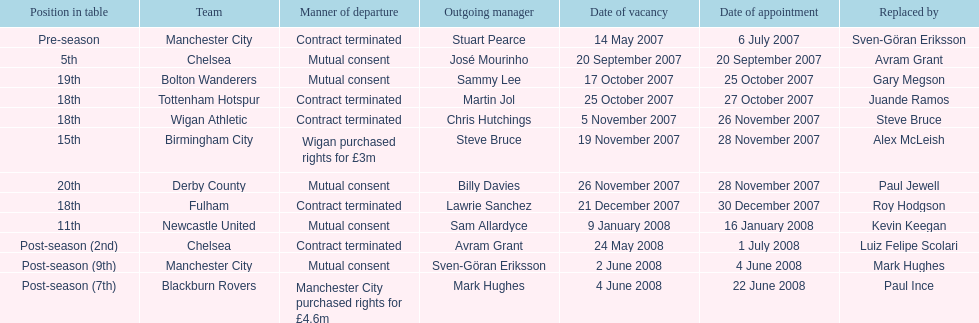Could you parse the entire table? {'header': ['Position in table', 'Team', 'Manner of departure', 'Outgoing manager', 'Date of vacancy', 'Date of appointment', 'Replaced by'], 'rows': [['Pre-season', 'Manchester City', 'Contract terminated', 'Stuart Pearce', '14 May 2007', '6 July 2007', 'Sven-Göran Eriksson'], ['5th', 'Chelsea', 'Mutual consent', 'José Mourinho', '20 September 2007', '20 September 2007', 'Avram Grant'], ['19th', 'Bolton Wanderers', 'Mutual consent', 'Sammy Lee', '17 October 2007', '25 October 2007', 'Gary Megson'], ['18th', 'Tottenham Hotspur', 'Contract terminated', 'Martin Jol', '25 October 2007', '27 October 2007', 'Juande Ramos'], ['18th', 'Wigan Athletic', 'Contract terminated', 'Chris Hutchings', '5 November 2007', '26 November 2007', 'Steve Bruce'], ['15th', 'Birmingham City', 'Wigan purchased rights for £3m', 'Steve Bruce', '19 November 2007', '28 November 2007', 'Alex McLeish'], ['20th', 'Derby County', 'Mutual consent', 'Billy Davies', '26 November 2007', '28 November 2007', 'Paul Jewell'], ['18th', 'Fulham', 'Contract terminated', 'Lawrie Sanchez', '21 December 2007', '30 December 2007', 'Roy Hodgson'], ['11th', 'Newcastle United', 'Mutual consent', 'Sam Allardyce', '9 January 2008', '16 January 2008', 'Kevin Keegan'], ['Post-season (2nd)', 'Chelsea', 'Contract terminated', 'Avram Grant', '24 May 2008', '1 July 2008', 'Luiz Felipe Scolari'], ['Post-season (9th)', 'Manchester City', 'Mutual consent', 'Sven-Göran Eriksson', '2 June 2008', '4 June 2008', 'Mark Hughes'], ['Post-season (7th)', 'Blackburn Rovers', 'Manchester City purchased rights for £4.6m', 'Mark Hughes', '4 June 2008', '22 June 2008', 'Paul Ince']]} What team is listed after manchester city? Chelsea. 